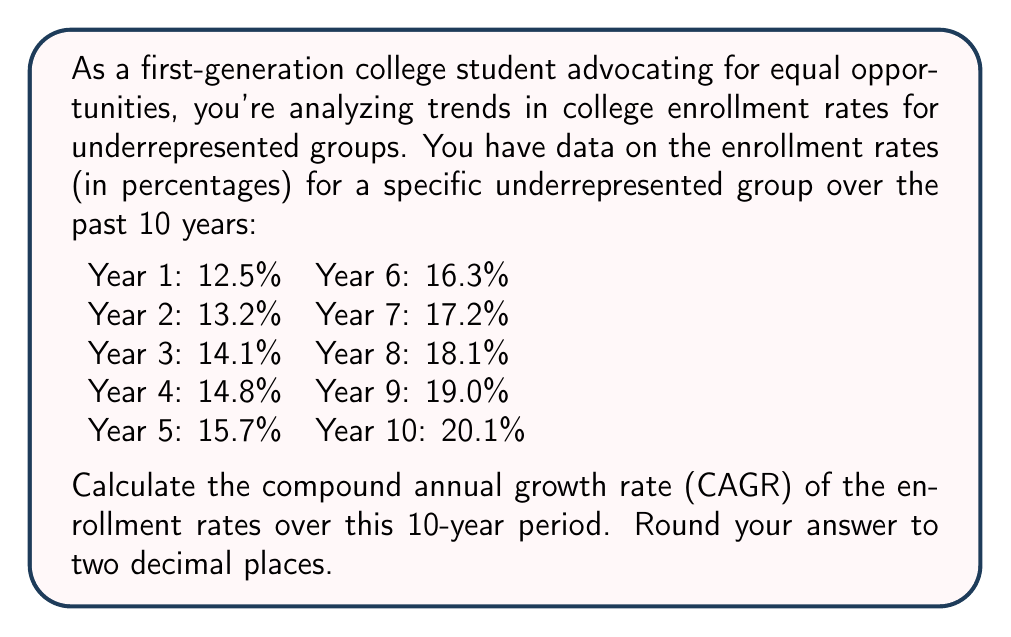Give your solution to this math problem. To calculate the Compound Annual Growth Rate (CAGR), we use the following formula:

$$ CAGR = \left(\frac{Ending Value}{Beginning Value}\right)^{\frac{1}{n}} - 1 $$

Where:
- Ending Value is the enrollment rate in Year 10
- Beginning Value is the enrollment rate in Year 1
- n is the number of years (10 in this case)

Let's plug in the values:

$$ CAGR = \left(\frac{20.1\%}{12.5\%}\right)^{\frac{1}{10}} - 1 $$

$$ CAGR = \left(\frac{0.201}{0.125}\right)^{0.1} - 1 $$

$$ CAGR = (1.608)^{0.1} - 1 $$

$$ CAGR = 1.0487 - 1 $$

$$ CAGR = 0.0487 $$

Converting to a percentage and rounding to two decimal places:

$$ CAGR = 4.87\% $$

This means that the enrollment rate for this underrepresented group grew at an average rate of 4.87% per year over the 10-year period.
Answer: 4.87% 